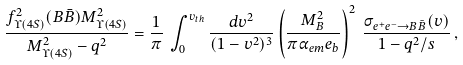Convert formula to latex. <formula><loc_0><loc_0><loc_500><loc_500>\frac { f _ { \Upsilon ( 4 S ) } ^ { 2 } ( B \bar { B } ) M ^ { 2 } _ { \Upsilon ( 4 S ) } } { M _ { \Upsilon ( 4 S ) } ^ { 2 } - q ^ { 2 } } = \frac { 1 } { \pi } \, \int _ { 0 } ^ { v _ { t h } } \frac { d v ^ { 2 } } { ( 1 - v ^ { 2 } ) ^ { 3 } } \left ( \frac { M _ { B } ^ { 2 } } { \pi \alpha _ { e m } e _ { b } } \right ) ^ { 2 } \, \frac { \sigma _ { e ^ { + } e ^ { - } \to B \bar { B } } ( v ) } { 1 - q ^ { 2 } / s } \, ,</formula> 